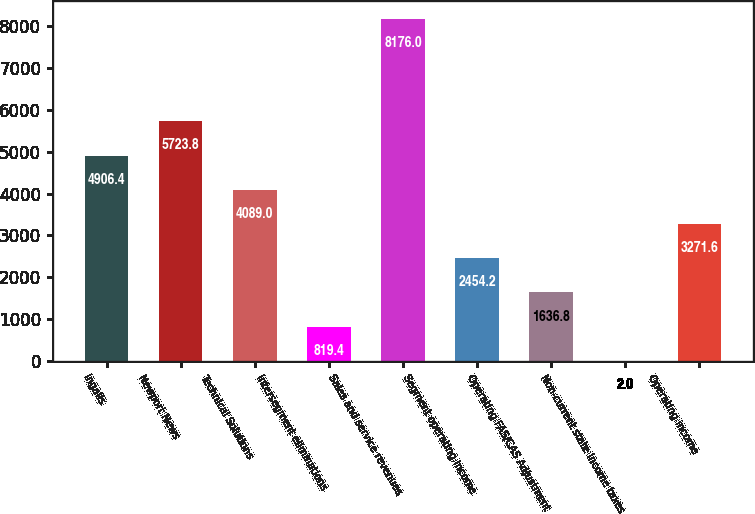Convert chart to OTSL. <chart><loc_0><loc_0><loc_500><loc_500><bar_chart><fcel>Ingalls<fcel>Newport News<fcel>Technical Solutions<fcel>Intersegment eliminations<fcel>Sales and service revenues<fcel>Segment operating income<fcel>Operating FAS/CAS Adjustment<fcel>Non-current state income taxes<fcel>Operating income<nl><fcel>4906.4<fcel>5723.8<fcel>4089<fcel>819.4<fcel>8176<fcel>2454.2<fcel>1636.8<fcel>2<fcel>3271.6<nl></chart> 